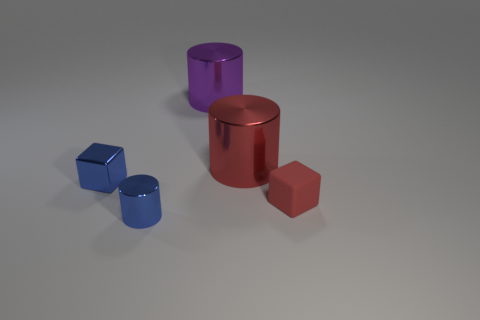Add 5 red metal cylinders. How many objects exist? 10 Subtract all cubes. How many objects are left? 3 Subtract all big red cylinders. Subtract all small blue shiny cubes. How many objects are left? 3 Add 1 cylinders. How many cylinders are left? 4 Add 4 large gray rubber cubes. How many large gray rubber cubes exist? 4 Subtract 0 cyan cubes. How many objects are left? 5 